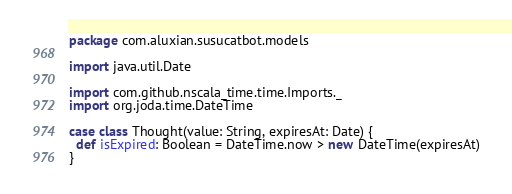<code> <loc_0><loc_0><loc_500><loc_500><_Scala_>package com.aluxian.susucatbot.models

import java.util.Date

import com.github.nscala_time.time.Imports._
import org.joda.time.DateTime

case class Thought(value: String, expiresAt: Date) {
  def isExpired: Boolean = DateTime.now > new DateTime(expiresAt)
}
</code> 